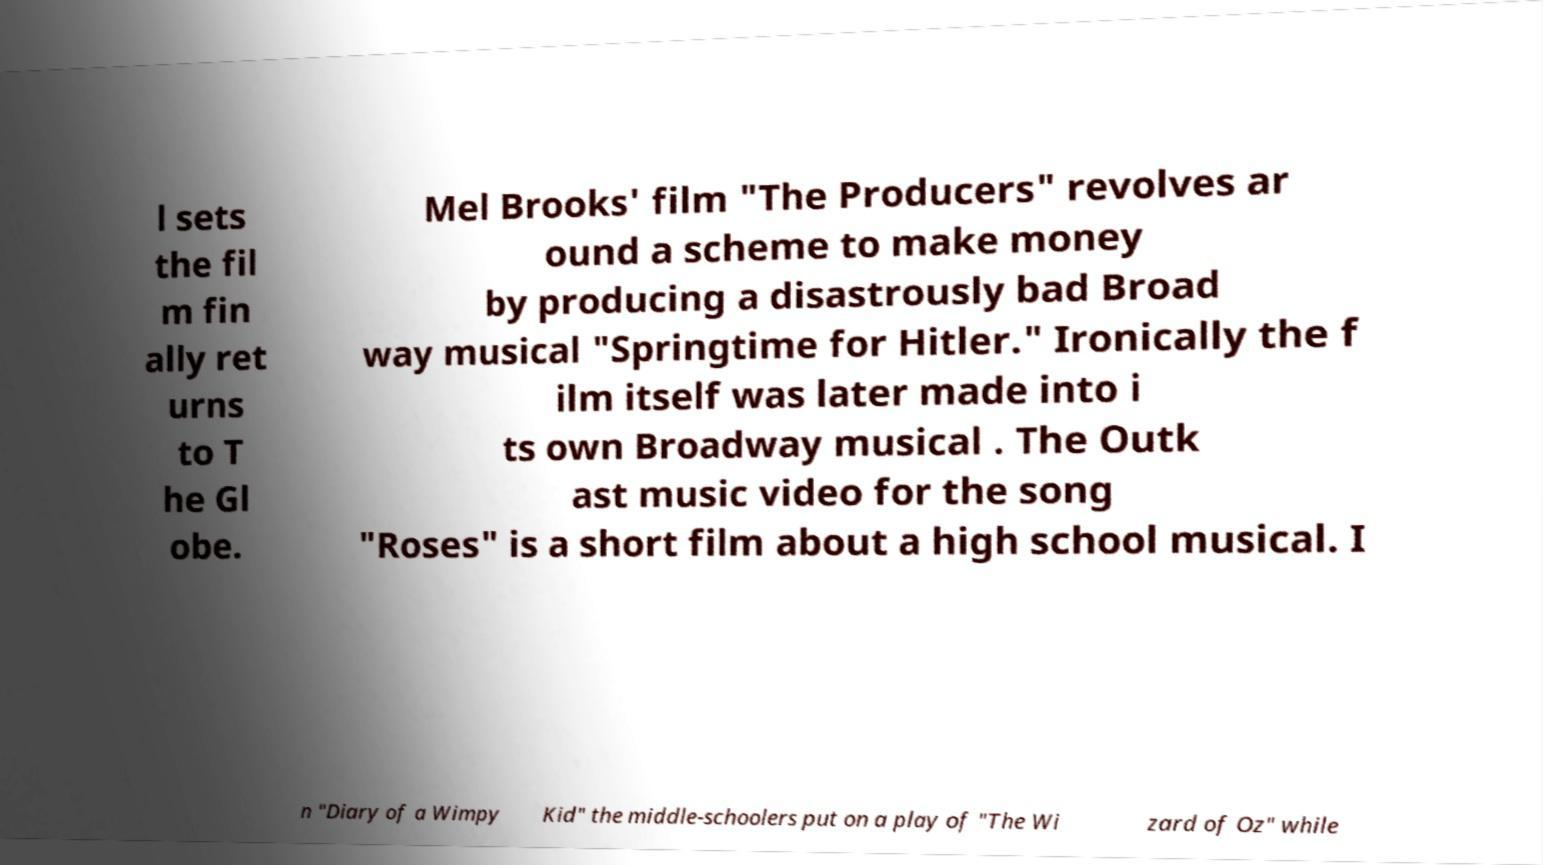Can you read and provide the text displayed in the image?This photo seems to have some interesting text. Can you extract and type it out for me? l sets the fil m fin ally ret urns to T he Gl obe. Mel Brooks' film "The Producers" revolves ar ound a scheme to make money by producing a disastrously bad Broad way musical "Springtime for Hitler." Ironically the f ilm itself was later made into i ts own Broadway musical . The Outk ast music video for the song "Roses" is a short film about a high school musical. I n "Diary of a Wimpy Kid" the middle-schoolers put on a play of "The Wi zard of Oz" while 